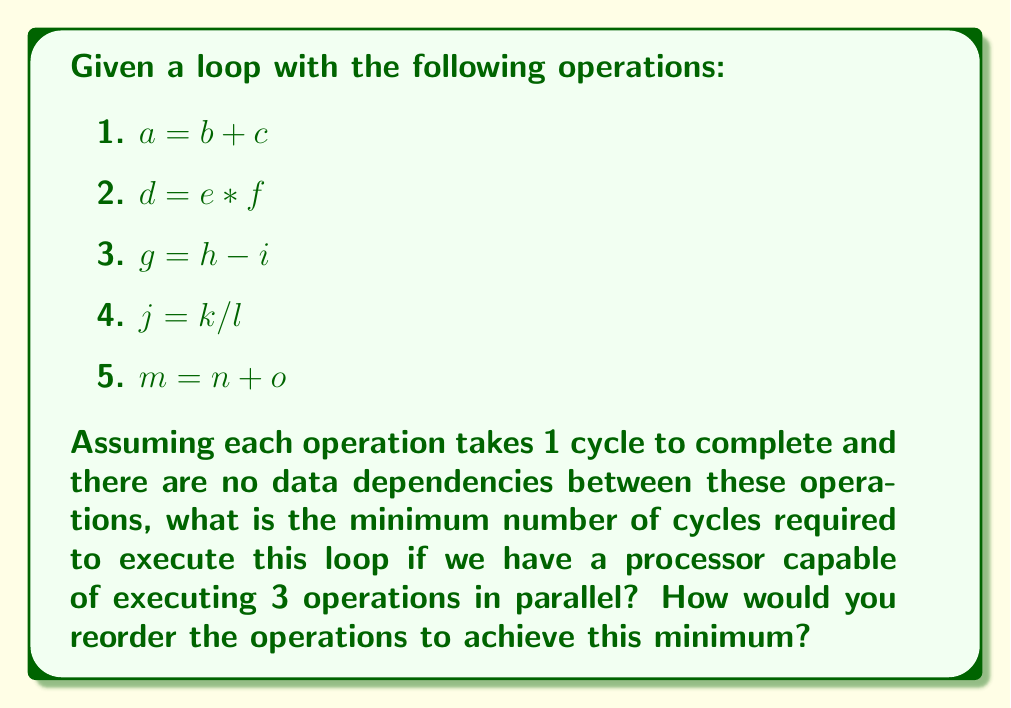Teach me how to tackle this problem. To minimize the number of cycles required to execute this loop, we need to maximize instruction-level parallelism by reordering the operations to take full advantage of the processor's capability to execute 3 operations in parallel.

Let's approach this step-by-step:

1. First, we count the total number of operations: There are 5 operations.

2. We know the processor can execute 3 operations in parallel per cycle.

3. To find the minimum number of cycles, we divide the total number of operations by the number of parallel operations possible, rounding up to the nearest integer:

   $$\text{Minimum cycles} = \left\lceil\frac{\text{Total operations}}{\text{Parallel operations}}\right\rceil = \left\lceil\frac{5}{3}\right\rceil = 2$$

4. To achieve this minimum, we need to reorder the operations so that we can execute 3 operations in the first cycle and the remaining 2 operations in the second cycle.

5. Since there are no data dependencies between the operations, we can arrange them in any order. One possible reordering is:

   Cycle 1:
   - $a = b + c$
   - $d = e * f$
   - $g = h - i$

   Cycle 2:
   - $j = k / l$
   - $m = n + o$

This arrangement fully utilizes the processor's capability in the first cycle and completes the remaining operations in the second cycle, achieving the minimum of 2 cycles.
Answer: The minimum number of cycles required is 2. One possible reordering to achieve this is:

Cycle 1: $a = b + c$, $d = e * f$, $g = h - i$
Cycle 2: $j = k / l$, $m = n + o$ 